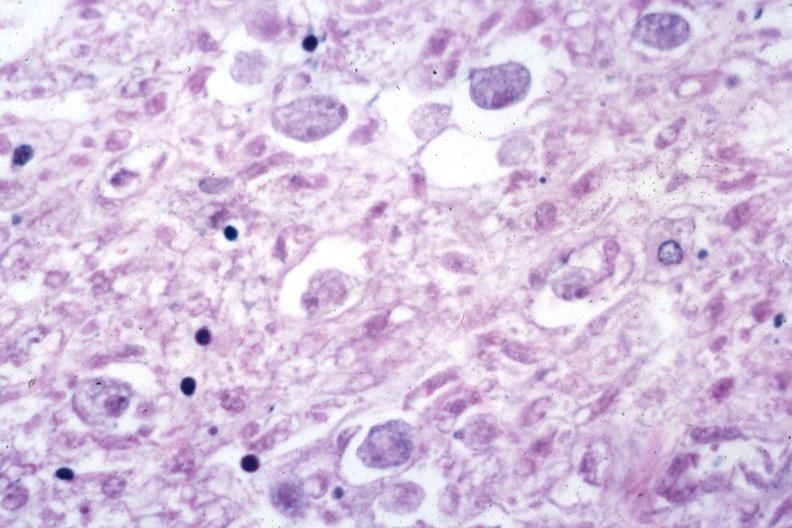does this image show trophozoites in tissue?
Answer the question using a single word or phrase. Yes 